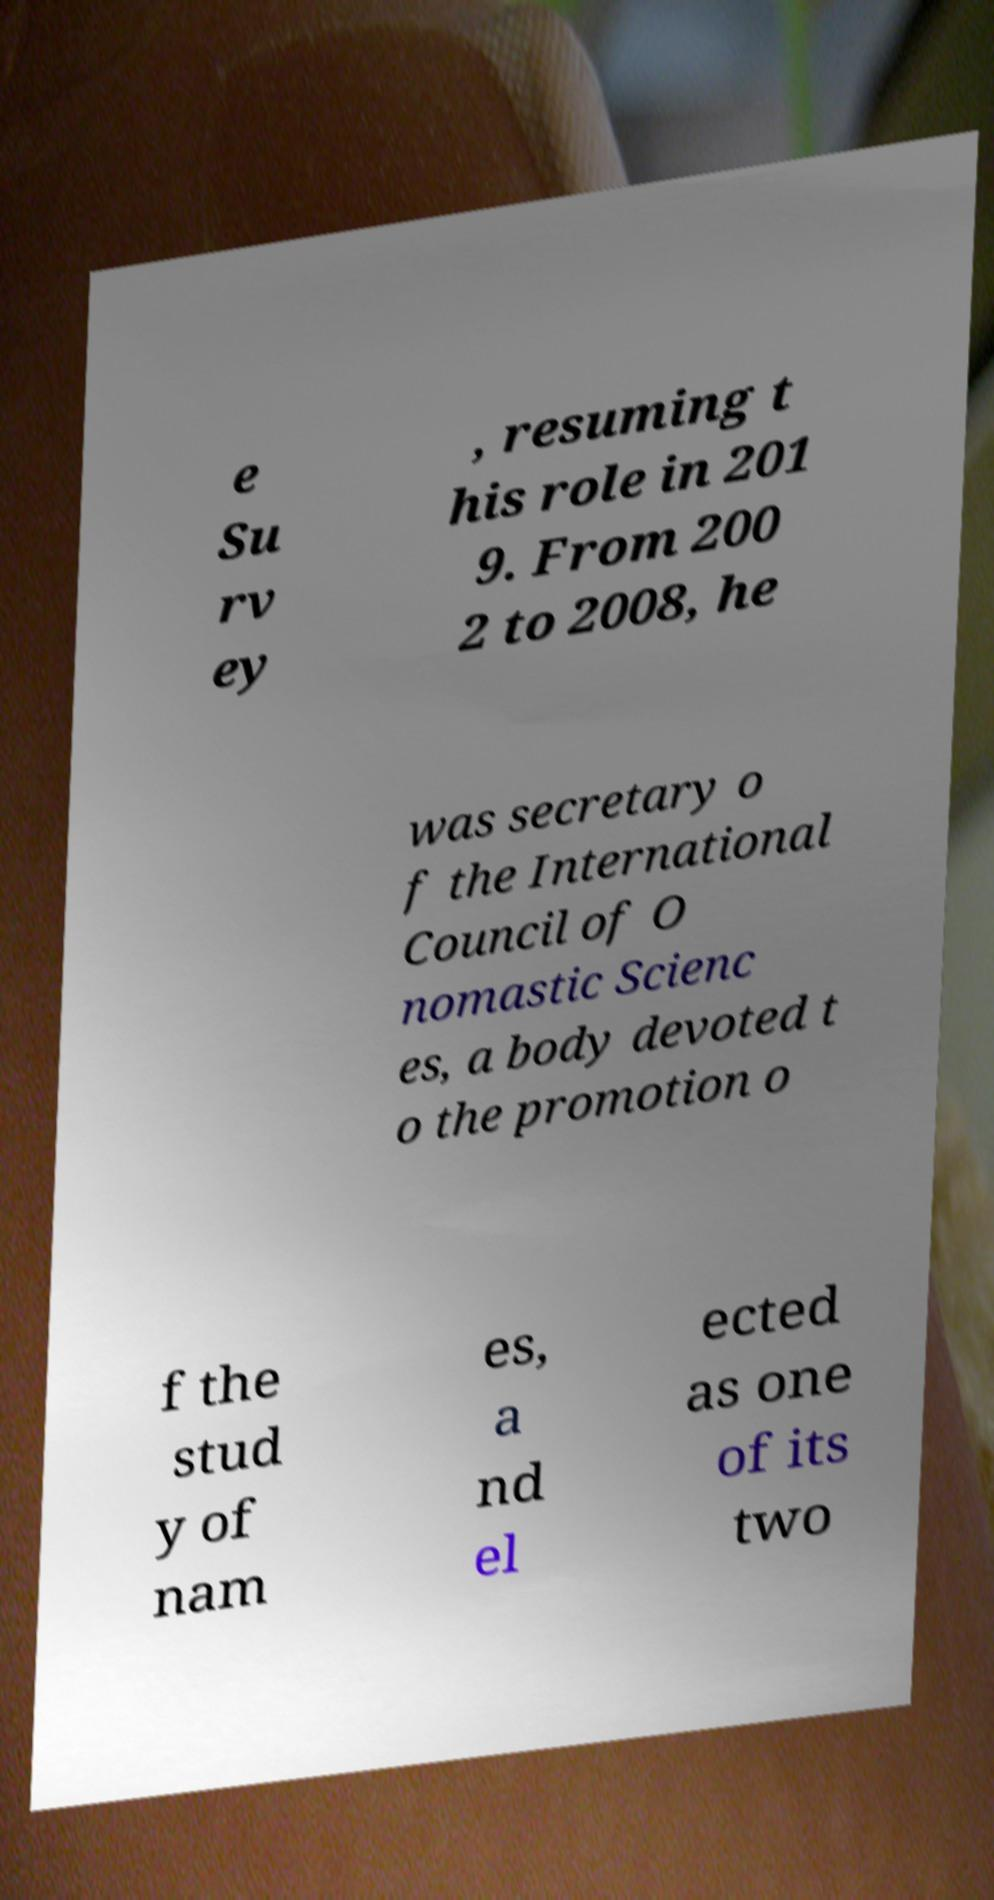I need the written content from this picture converted into text. Can you do that? e Su rv ey , resuming t his role in 201 9. From 200 2 to 2008, he was secretary o f the International Council of O nomastic Scienc es, a body devoted t o the promotion o f the stud y of nam es, a nd el ected as one of its two 